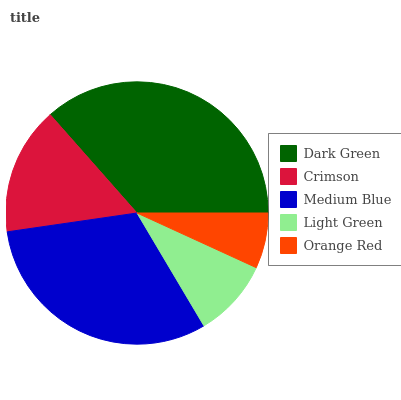Is Orange Red the minimum?
Answer yes or no. Yes. Is Dark Green the maximum?
Answer yes or no. Yes. Is Crimson the minimum?
Answer yes or no. No. Is Crimson the maximum?
Answer yes or no. No. Is Dark Green greater than Crimson?
Answer yes or no. Yes. Is Crimson less than Dark Green?
Answer yes or no. Yes. Is Crimson greater than Dark Green?
Answer yes or no. No. Is Dark Green less than Crimson?
Answer yes or no. No. Is Crimson the high median?
Answer yes or no. Yes. Is Crimson the low median?
Answer yes or no. Yes. Is Orange Red the high median?
Answer yes or no. No. Is Light Green the low median?
Answer yes or no. No. 